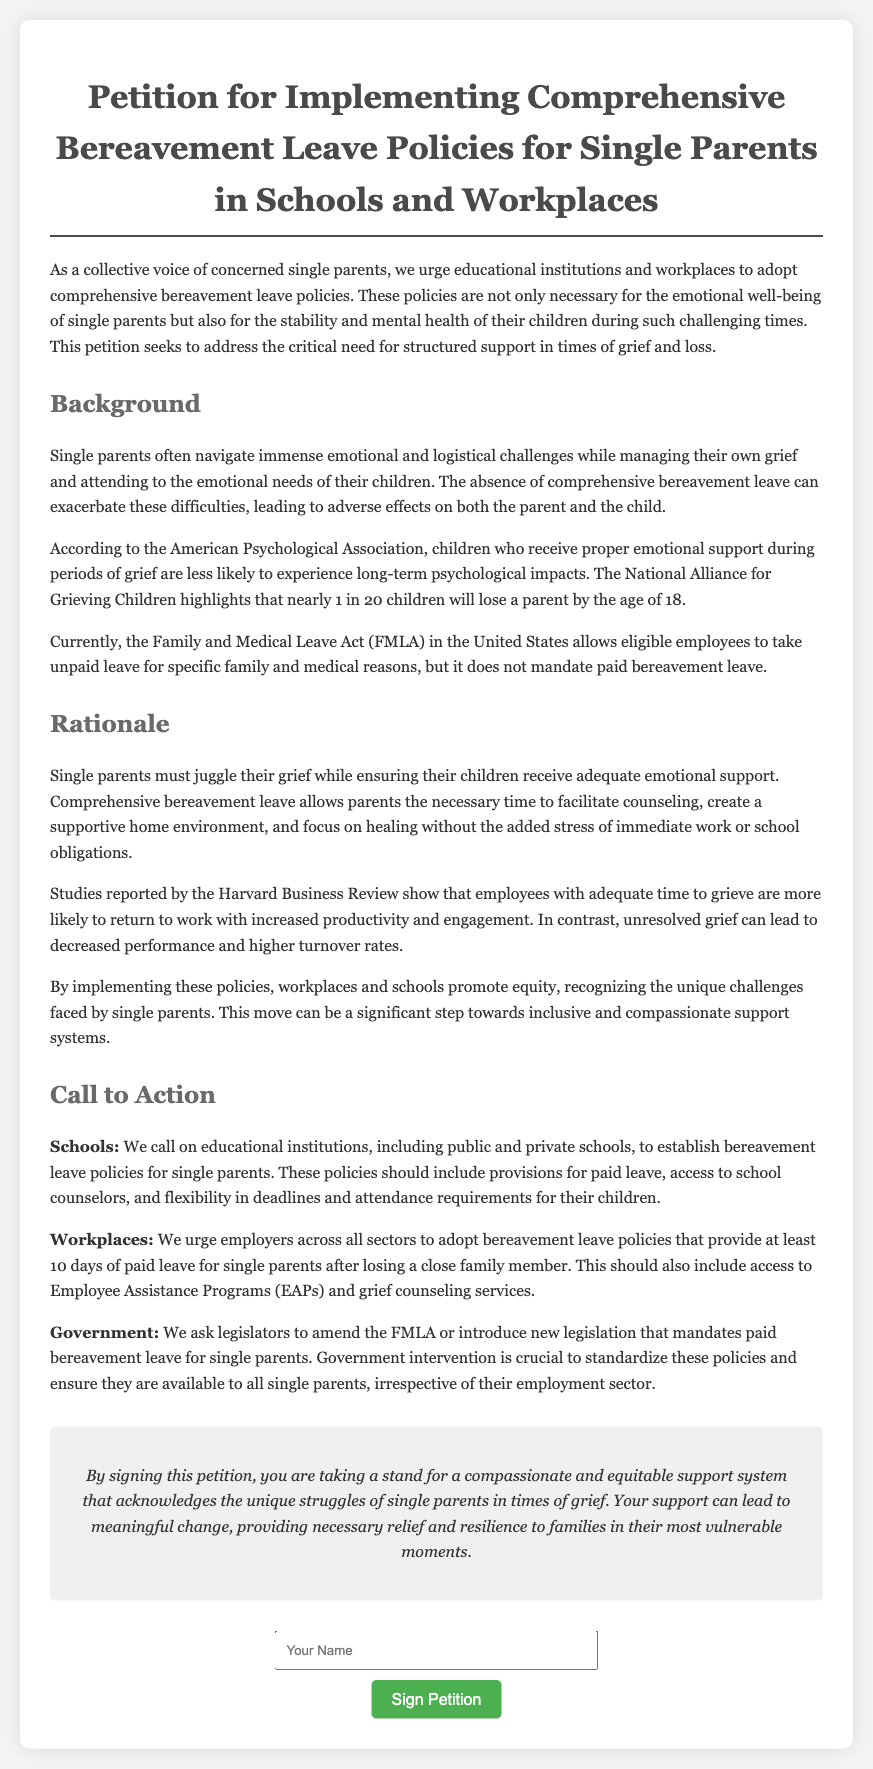What is the title of the petition? The title of the petition is the main heading of the document located at the top, highlighting its purpose.
Answer: Petition for Implementing Comprehensive Bereavement Leave Policies for Single Parents in Schools and Workplaces How many days of paid leave are urged for single parents after a loss? The document specifies that workplaces should provide at least 10 days of paid leave after losing a close family member.
Answer: 10 days What organization does the petition reference for statistical support regarding children and grief? The document mentions the National Alliance for Grieving Children, which is cited for providing key statistics related to children losing a parent.
Answer: National Alliance for Grieving Children What is the main reason for needing comprehensive bereavement leave policies? The rationale indicates that single parents navigate emotional challenges and need time to support their children effectively during grief.
Answer: Emotional well-being What populations does the petition address in its call to action? The petition calls on schools, workplaces, and government entities to support the implementation of bereavement leave policies.
Answer: Schools, workplaces, and government What psychological organization is mentioned regarding the impact of emotional support on children? The document refers to the American Psychological Association which discusses the psychological impacts on children receiving support during grief.
Answer: American Psychological Association What should educational institutions provide according to the petition? Schools are encouraged to establish bereavement leave policies including provisions for paid leave and access to school counselors.
Answer: Paid leave and access to school counselors What is the purpose of signing the petition? The purpose of signing the petition is for individuals to advocate for a compassionate support system acknowledging the struggles of single parents during grief.
Answer: Advocate for a compassionate support system 